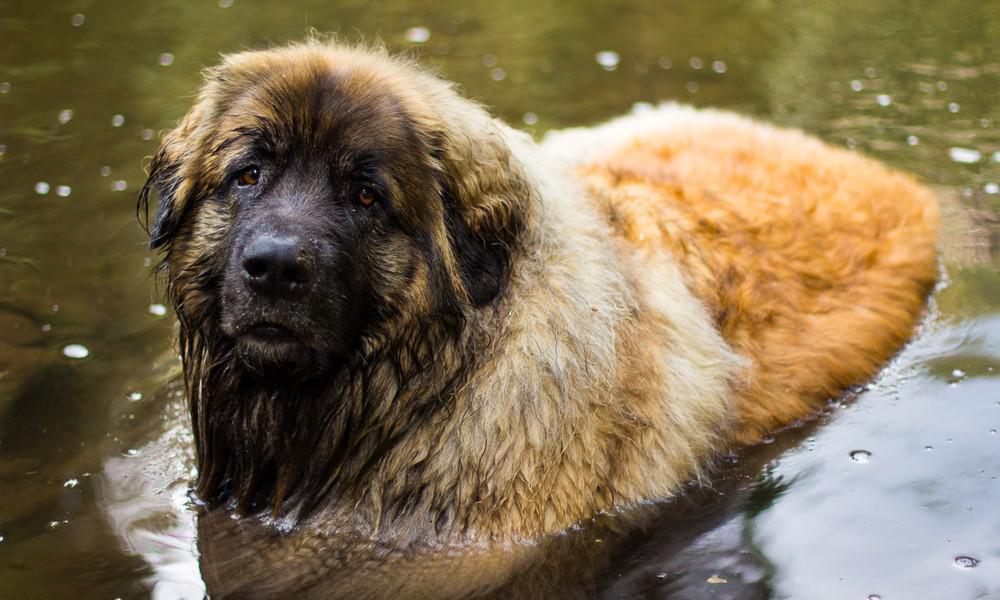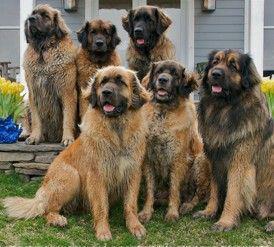The first image is the image on the left, the second image is the image on the right. Examine the images to the left and right. Is the description "One image shows at least five similar looking dogs posed sitting upright on grass in front of a house, with no humans present." accurate? Answer yes or no. Yes. The first image is the image on the left, the second image is the image on the right. For the images displayed, is the sentence "There are no more than two dogs in the right image." factually correct? Answer yes or no. No. 